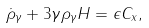<formula> <loc_0><loc_0><loc_500><loc_500>\dot { \rho } _ { \gamma } + 3 \gamma \rho _ { \gamma } H = \epsilon C _ { x } ,</formula> 